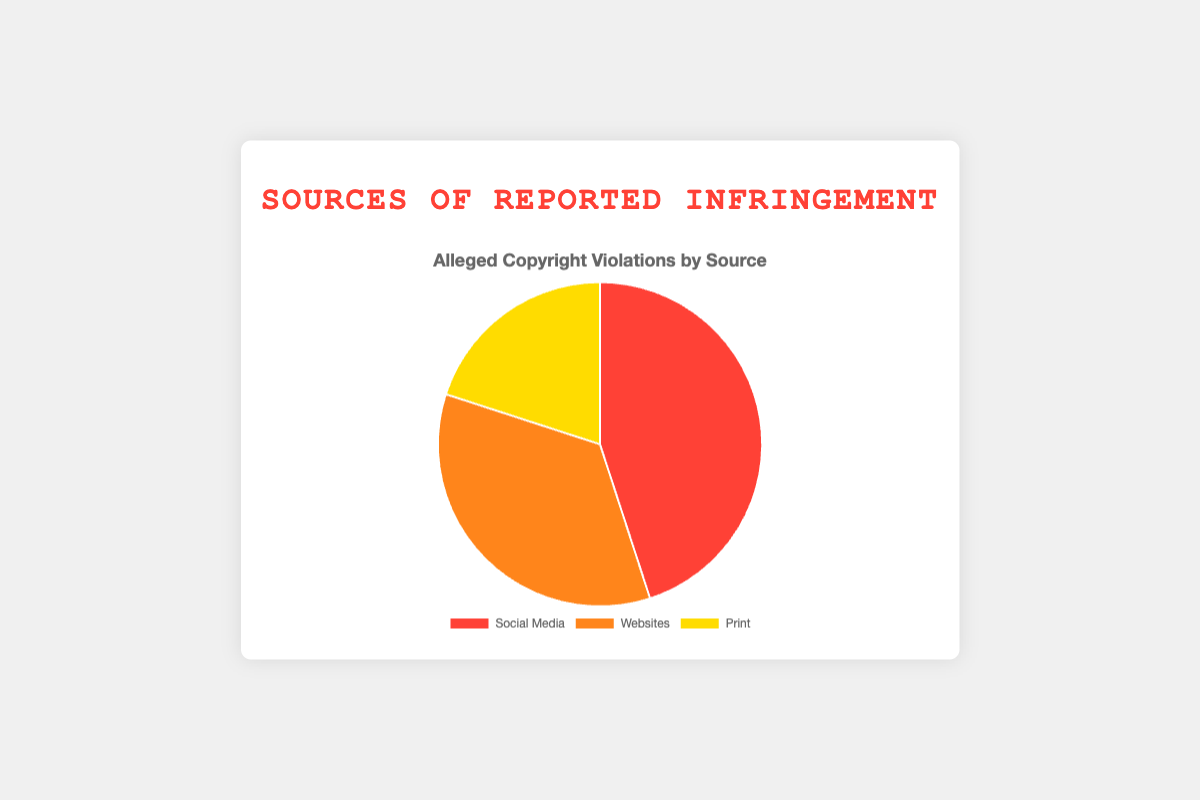Which source has the highest reported infringement percentage? Social Media has the highest percentage at 45%. You can directly see from the pie chart that the largest segment corresponds to Social Media.
Answer: Social Media What is the difference in reported infringement percentages between Social Media and Print? Social Media has 45% and Print has 20%. The difference is 45% - 20% = 25%.
Answer: 25% What is the total percentage of reported infringements for both Websites and Print combined? Websites have 35% and Print has 20%. The sum is 35% + 20% = 55%.
Answer: 55% Which sources have the combined percentage equal to that of Social Media alone? Websites (35%) and Print (20%) combined equal Social Media's 45%. You can see that the sum of the two segments matches the percentage of the larger segment.
Answer: Websites and Print What is the ratio of reported infringements between Websites and Social Media? Websites have 35% and Social Media has 45%. The ratio is 35:45, which simplifies to 7:9.
Answer: 7:9 Which source is represented by the yellow color in the pie chart? The yellow color represents Print. You can identify this by looking at the color legend in the pie chart.
Answer: Print What is the average reported infringement percentage for all sources? The percentages are 45% (Social Media), 35% (Websites), and 20% (Print). The sum is 45 + 35 + 20 = 100. The average is 100/3 ≈ 33.33%.
Answer: ~33.33% Which source's percentage is halfway between the highest and the lowest reported infringement percentages? The highest percentage is 45% (Social Media) and the lowest is 20% (Print). Halfway between these is (45% + 20%) / 2 = 32.5%. The closest source to this value is Websites with 35%.
Answer: Websites If the percentage of Print were to increase by 10%, what would the new total percentage be? Print currently has 20%. Increasing by 10% gives 20% + 10% = 30%. The new total is 45% (Social Media) + 35% (Websites) + 30% (Print) = 110%.
Answer: 110% 